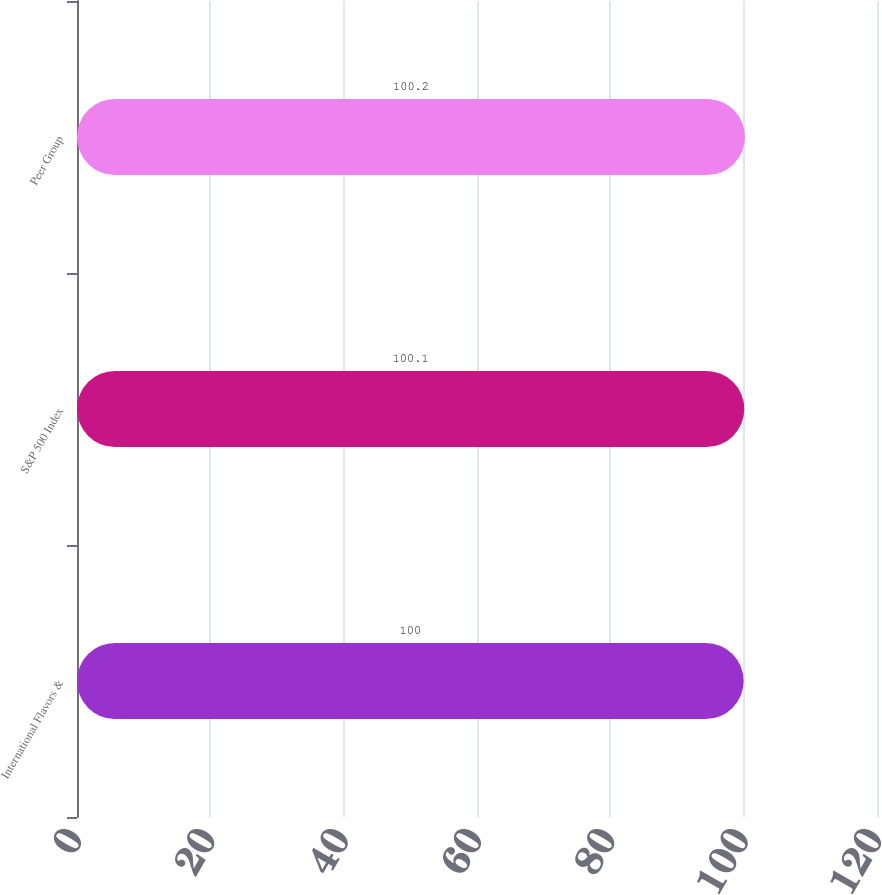<chart> <loc_0><loc_0><loc_500><loc_500><bar_chart><fcel>International Flavors &<fcel>S&P 500 Index<fcel>Peer Group<nl><fcel>100<fcel>100.1<fcel>100.2<nl></chart> 